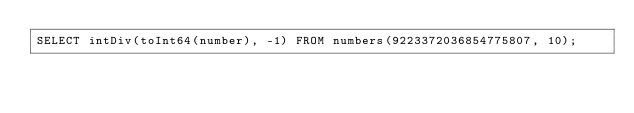<code> <loc_0><loc_0><loc_500><loc_500><_SQL_>SELECT intDiv(toInt64(number), -1) FROM numbers(9223372036854775807, 10);
</code> 